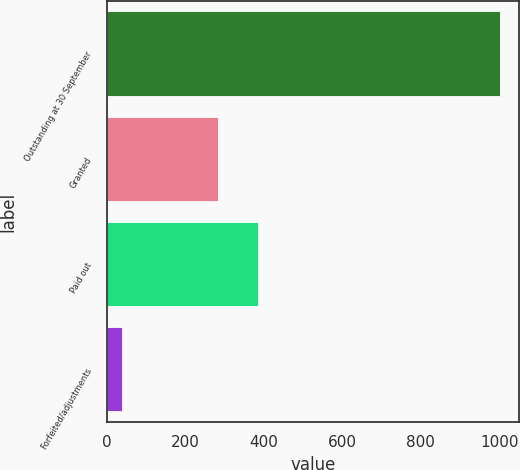Convert chart to OTSL. <chart><loc_0><loc_0><loc_500><loc_500><bar_chart><fcel>Outstanding at 30 September<fcel>Granted<fcel>Paid out<fcel>Forfeited/adjustments<nl><fcel>1001<fcel>284<fcel>385.6<fcel>40<nl></chart> 